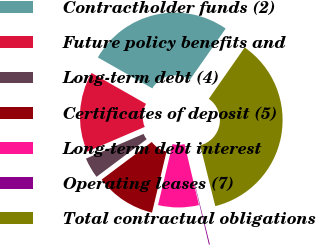Convert chart. <chart><loc_0><loc_0><loc_500><loc_500><pie_chart><fcel>Contractholder funds (2)<fcel>Future policy benefits and<fcel>Long-term debt (4)<fcel>Certificates of deposit (5)<fcel>Long-term debt interest<fcel>Operating leases (7)<fcel>Total contractual obligations<nl><fcel>26.48%<fcel>14.67%<fcel>3.79%<fcel>11.04%<fcel>7.42%<fcel>0.17%<fcel>36.43%<nl></chart> 